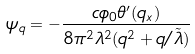Convert formula to latex. <formula><loc_0><loc_0><loc_500><loc_500>\psi _ { q } = - \frac { c \phi _ { 0 } \theta ^ { \prime } ( q _ { x } ) } { 8 \pi ^ { 2 } \lambda ^ { 2 } ( q ^ { 2 } + q / \tilde { \lambda } ) }</formula> 